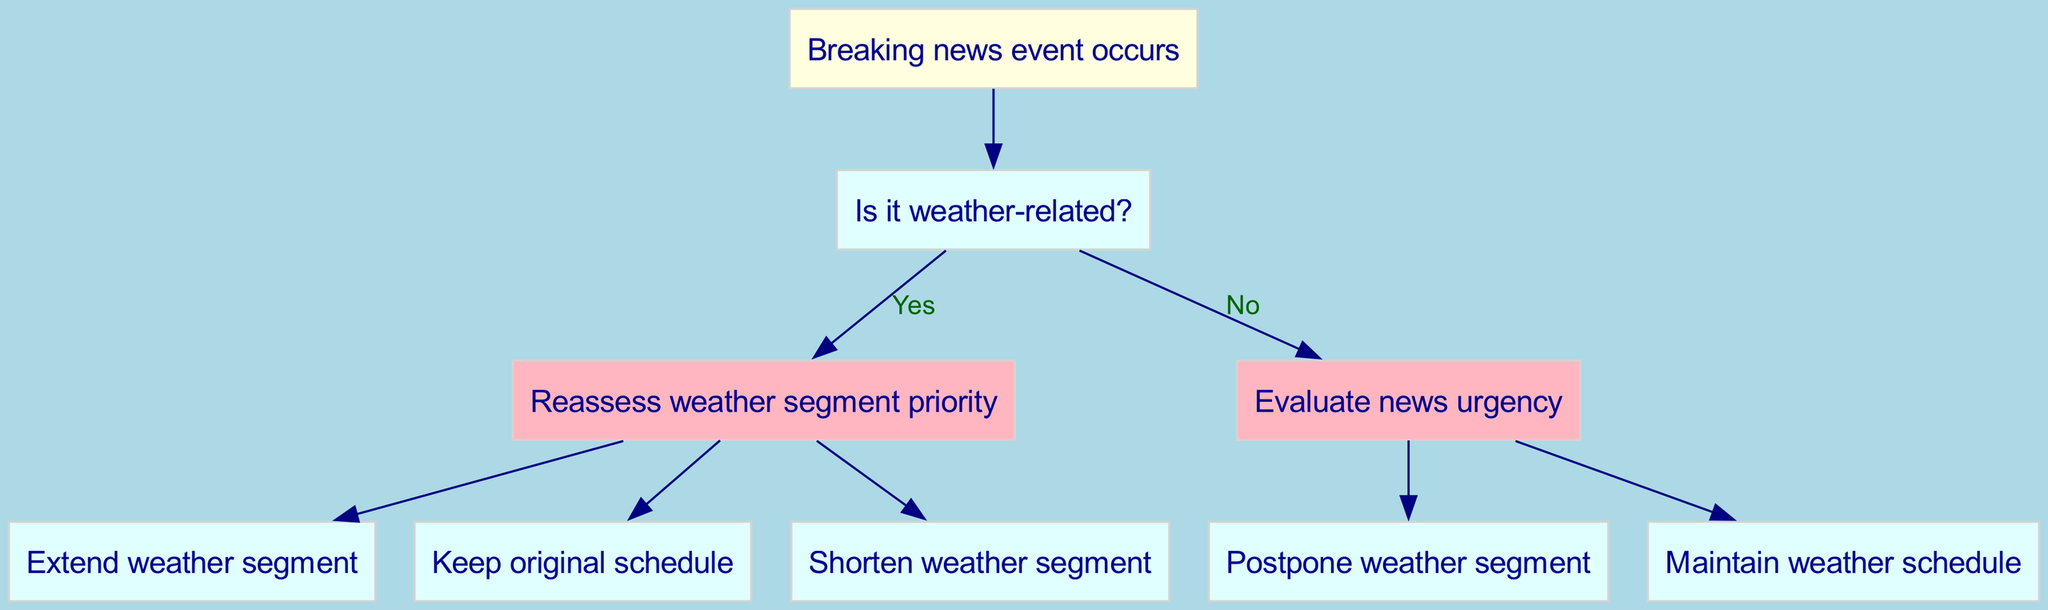What is the root of the decision tree? The diagram's root is defined as "Breaking news event occurs." This is the starting point from which all decisions branch out.
Answer: Breaking news event occurs How many edges are there from the "Is it weather-related?" node? From the "Is it weather-related?" node, there are two edges: one leading to "Reassess weather segment priority" and another leading to "Evaluate news urgency." These edges indicate the possible decision directions based on whether the breaking news is weather-related.
Answer: 2 What happens if the impact of the weather-related event is low? If the impact is determined to be low, the decision flows to the node "Shorten weather segment," which indicates that the weather segment would be shortened due to the low impact of the event.
Answer: Shorten weather segment What action is taken if the breaking news is non-urgent? If the breaking news is evaluated as non-urgent, the flow leads to "Maintain weather schedule," meaning that the original weather segment schedule will remain unchanged despite the breaking news.
Answer: Maintain weather schedule If a breaking news event is urgent and weather-related, how will the weather segment be prioritized? The tree specifies that if the breaking news is urgent, the flow does not lead to the weather-related impact but rather directly to "Postpone weather segment." The urgency of the news takes precedence over weather-related considerations.
Answer: Postpone weather segment Which node has the highest priority based on the decisions? The highest priority in the decision tree is given to the "Reassess weather segment priority" node directly after determining if the breaking news is weather-related, indicating that this is where critical decisions about weather segments are made.
Answer: Reassess weather segment priority What type of node follows after confirming a weather-related breaking news event with high impact? Following a weather-related breaking news event assessed as high impact, the node that follows is "Extend weather segment." This indicates that significant weather-related events necessitate expanding the coverage time of the weather segment.
Answer: Extend weather segment 